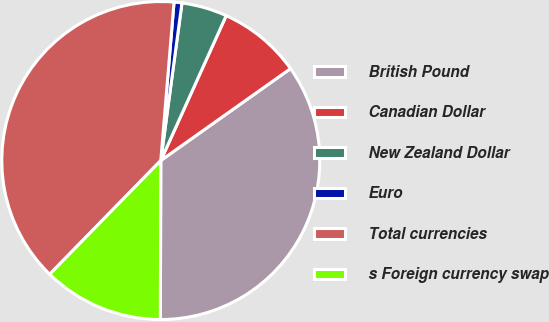Convert chart to OTSL. <chart><loc_0><loc_0><loc_500><loc_500><pie_chart><fcel>British Pound<fcel>Canadian Dollar<fcel>New Zealand Dollar<fcel>Euro<fcel>Total currencies<fcel>s Foreign currency swap<nl><fcel>34.85%<fcel>8.44%<fcel>4.62%<fcel>0.8%<fcel>39.01%<fcel>12.27%<nl></chart> 